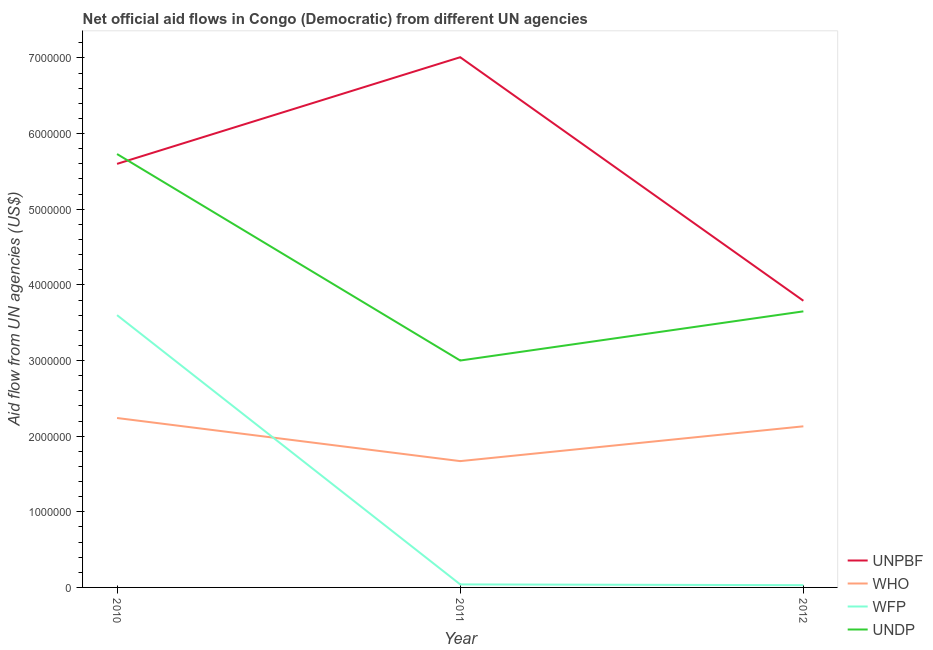How many different coloured lines are there?
Keep it short and to the point. 4. What is the amount of aid given by wfp in 2011?
Offer a very short reply. 4.00e+04. Across all years, what is the maximum amount of aid given by who?
Provide a short and direct response. 2.24e+06. Across all years, what is the minimum amount of aid given by unpbf?
Your answer should be very brief. 3.79e+06. What is the total amount of aid given by who in the graph?
Offer a very short reply. 6.04e+06. What is the difference between the amount of aid given by unpbf in 2010 and that in 2011?
Ensure brevity in your answer.  -1.41e+06. What is the difference between the amount of aid given by wfp in 2012 and the amount of aid given by unpbf in 2010?
Make the answer very short. -5.57e+06. What is the average amount of aid given by wfp per year?
Offer a very short reply. 1.22e+06. In the year 2011, what is the difference between the amount of aid given by unpbf and amount of aid given by who?
Your answer should be very brief. 5.34e+06. In how many years, is the amount of aid given by undp greater than 400000 US$?
Your answer should be very brief. 3. What is the ratio of the amount of aid given by undp in 2010 to that in 2012?
Keep it short and to the point. 1.57. Is the difference between the amount of aid given by who in 2010 and 2011 greater than the difference between the amount of aid given by unpbf in 2010 and 2011?
Offer a very short reply. Yes. What is the difference between the highest and the second highest amount of aid given by unpbf?
Offer a terse response. 1.41e+06. What is the difference between the highest and the lowest amount of aid given by unpbf?
Provide a succinct answer. 3.22e+06. In how many years, is the amount of aid given by who greater than the average amount of aid given by who taken over all years?
Your answer should be very brief. 2. Is the amount of aid given by unpbf strictly greater than the amount of aid given by undp over the years?
Ensure brevity in your answer.  No. Is the amount of aid given by wfp strictly less than the amount of aid given by undp over the years?
Your response must be concise. Yes. What is the difference between two consecutive major ticks on the Y-axis?
Provide a succinct answer. 1.00e+06. How many legend labels are there?
Ensure brevity in your answer.  4. How are the legend labels stacked?
Provide a short and direct response. Vertical. What is the title of the graph?
Ensure brevity in your answer.  Net official aid flows in Congo (Democratic) from different UN agencies. Does "Agriculture" appear as one of the legend labels in the graph?
Offer a very short reply. No. What is the label or title of the X-axis?
Provide a succinct answer. Year. What is the label or title of the Y-axis?
Give a very brief answer. Aid flow from UN agencies (US$). What is the Aid flow from UN agencies (US$) of UNPBF in 2010?
Keep it short and to the point. 5.60e+06. What is the Aid flow from UN agencies (US$) of WHO in 2010?
Your answer should be compact. 2.24e+06. What is the Aid flow from UN agencies (US$) of WFP in 2010?
Ensure brevity in your answer.  3.60e+06. What is the Aid flow from UN agencies (US$) of UNDP in 2010?
Provide a succinct answer. 5.73e+06. What is the Aid flow from UN agencies (US$) in UNPBF in 2011?
Give a very brief answer. 7.01e+06. What is the Aid flow from UN agencies (US$) in WHO in 2011?
Offer a very short reply. 1.67e+06. What is the Aid flow from UN agencies (US$) of UNDP in 2011?
Your response must be concise. 3.00e+06. What is the Aid flow from UN agencies (US$) in UNPBF in 2012?
Offer a very short reply. 3.79e+06. What is the Aid flow from UN agencies (US$) in WHO in 2012?
Your response must be concise. 2.13e+06. What is the Aid flow from UN agencies (US$) in WFP in 2012?
Your response must be concise. 3.00e+04. What is the Aid flow from UN agencies (US$) of UNDP in 2012?
Provide a succinct answer. 3.65e+06. Across all years, what is the maximum Aid flow from UN agencies (US$) in UNPBF?
Your answer should be very brief. 7.01e+06. Across all years, what is the maximum Aid flow from UN agencies (US$) in WHO?
Provide a succinct answer. 2.24e+06. Across all years, what is the maximum Aid flow from UN agencies (US$) in WFP?
Your answer should be very brief. 3.60e+06. Across all years, what is the maximum Aid flow from UN agencies (US$) of UNDP?
Your answer should be very brief. 5.73e+06. Across all years, what is the minimum Aid flow from UN agencies (US$) of UNPBF?
Keep it short and to the point. 3.79e+06. Across all years, what is the minimum Aid flow from UN agencies (US$) of WHO?
Your response must be concise. 1.67e+06. Across all years, what is the minimum Aid flow from UN agencies (US$) in UNDP?
Your answer should be very brief. 3.00e+06. What is the total Aid flow from UN agencies (US$) in UNPBF in the graph?
Provide a succinct answer. 1.64e+07. What is the total Aid flow from UN agencies (US$) in WHO in the graph?
Ensure brevity in your answer.  6.04e+06. What is the total Aid flow from UN agencies (US$) in WFP in the graph?
Offer a very short reply. 3.67e+06. What is the total Aid flow from UN agencies (US$) in UNDP in the graph?
Offer a terse response. 1.24e+07. What is the difference between the Aid flow from UN agencies (US$) of UNPBF in 2010 and that in 2011?
Keep it short and to the point. -1.41e+06. What is the difference between the Aid flow from UN agencies (US$) of WHO in 2010 and that in 2011?
Provide a succinct answer. 5.70e+05. What is the difference between the Aid flow from UN agencies (US$) of WFP in 2010 and that in 2011?
Offer a terse response. 3.56e+06. What is the difference between the Aid flow from UN agencies (US$) of UNDP in 2010 and that in 2011?
Provide a short and direct response. 2.73e+06. What is the difference between the Aid flow from UN agencies (US$) in UNPBF in 2010 and that in 2012?
Provide a succinct answer. 1.81e+06. What is the difference between the Aid flow from UN agencies (US$) in WHO in 2010 and that in 2012?
Your answer should be very brief. 1.10e+05. What is the difference between the Aid flow from UN agencies (US$) in WFP in 2010 and that in 2012?
Provide a short and direct response. 3.57e+06. What is the difference between the Aid flow from UN agencies (US$) in UNDP in 2010 and that in 2012?
Give a very brief answer. 2.08e+06. What is the difference between the Aid flow from UN agencies (US$) of UNPBF in 2011 and that in 2012?
Keep it short and to the point. 3.22e+06. What is the difference between the Aid flow from UN agencies (US$) in WHO in 2011 and that in 2012?
Keep it short and to the point. -4.60e+05. What is the difference between the Aid flow from UN agencies (US$) in WFP in 2011 and that in 2012?
Provide a succinct answer. 10000. What is the difference between the Aid flow from UN agencies (US$) in UNDP in 2011 and that in 2012?
Give a very brief answer. -6.50e+05. What is the difference between the Aid flow from UN agencies (US$) in UNPBF in 2010 and the Aid flow from UN agencies (US$) in WHO in 2011?
Make the answer very short. 3.93e+06. What is the difference between the Aid flow from UN agencies (US$) of UNPBF in 2010 and the Aid flow from UN agencies (US$) of WFP in 2011?
Ensure brevity in your answer.  5.56e+06. What is the difference between the Aid flow from UN agencies (US$) of UNPBF in 2010 and the Aid flow from UN agencies (US$) of UNDP in 2011?
Make the answer very short. 2.60e+06. What is the difference between the Aid flow from UN agencies (US$) of WHO in 2010 and the Aid flow from UN agencies (US$) of WFP in 2011?
Your response must be concise. 2.20e+06. What is the difference between the Aid flow from UN agencies (US$) of WHO in 2010 and the Aid flow from UN agencies (US$) of UNDP in 2011?
Your answer should be very brief. -7.60e+05. What is the difference between the Aid flow from UN agencies (US$) of WFP in 2010 and the Aid flow from UN agencies (US$) of UNDP in 2011?
Ensure brevity in your answer.  6.00e+05. What is the difference between the Aid flow from UN agencies (US$) in UNPBF in 2010 and the Aid flow from UN agencies (US$) in WHO in 2012?
Your response must be concise. 3.47e+06. What is the difference between the Aid flow from UN agencies (US$) of UNPBF in 2010 and the Aid flow from UN agencies (US$) of WFP in 2012?
Provide a short and direct response. 5.57e+06. What is the difference between the Aid flow from UN agencies (US$) of UNPBF in 2010 and the Aid flow from UN agencies (US$) of UNDP in 2012?
Offer a very short reply. 1.95e+06. What is the difference between the Aid flow from UN agencies (US$) in WHO in 2010 and the Aid flow from UN agencies (US$) in WFP in 2012?
Ensure brevity in your answer.  2.21e+06. What is the difference between the Aid flow from UN agencies (US$) of WHO in 2010 and the Aid flow from UN agencies (US$) of UNDP in 2012?
Offer a terse response. -1.41e+06. What is the difference between the Aid flow from UN agencies (US$) in UNPBF in 2011 and the Aid flow from UN agencies (US$) in WHO in 2012?
Your answer should be compact. 4.88e+06. What is the difference between the Aid flow from UN agencies (US$) in UNPBF in 2011 and the Aid flow from UN agencies (US$) in WFP in 2012?
Provide a succinct answer. 6.98e+06. What is the difference between the Aid flow from UN agencies (US$) of UNPBF in 2011 and the Aid flow from UN agencies (US$) of UNDP in 2012?
Your answer should be compact. 3.36e+06. What is the difference between the Aid flow from UN agencies (US$) of WHO in 2011 and the Aid flow from UN agencies (US$) of WFP in 2012?
Offer a terse response. 1.64e+06. What is the difference between the Aid flow from UN agencies (US$) of WHO in 2011 and the Aid flow from UN agencies (US$) of UNDP in 2012?
Provide a short and direct response. -1.98e+06. What is the difference between the Aid flow from UN agencies (US$) in WFP in 2011 and the Aid flow from UN agencies (US$) in UNDP in 2012?
Ensure brevity in your answer.  -3.61e+06. What is the average Aid flow from UN agencies (US$) in UNPBF per year?
Ensure brevity in your answer.  5.47e+06. What is the average Aid flow from UN agencies (US$) in WHO per year?
Provide a short and direct response. 2.01e+06. What is the average Aid flow from UN agencies (US$) of WFP per year?
Offer a terse response. 1.22e+06. What is the average Aid flow from UN agencies (US$) of UNDP per year?
Ensure brevity in your answer.  4.13e+06. In the year 2010, what is the difference between the Aid flow from UN agencies (US$) of UNPBF and Aid flow from UN agencies (US$) of WHO?
Your answer should be compact. 3.36e+06. In the year 2010, what is the difference between the Aid flow from UN agencies (US$) in UNPBF and Aid flow from UN agencies (US$) in WFP?
Provide a succinct answer. 2.00e+06. In the year 2010, what is the difference between the Aid flow from UN agencies (US$) of WHO and Aid flow from UN agencies (US$) of WFP?
Ensure brevity in your answer.  -1.36e+06. In the year 2010, what is the difference between the Aid flow from UN agencies (US$) in WHO and Aid flow from UN agencies (US$) in UNDP?
Give a very brief answer. -3.49e+06. In the year 2010, what is the difference between the Aid flow from UN agencies (US$) in WFP and Aid flow from UN agencies (US$) in UNDP?
Your response must be concise. -2.13e+06. In the year 2011, what is the difference between the Aid flow from UN agencies (US$) in UNPBF and Aid flow from UN agencies (US$) in WHO?
Give a very brief answer. 5.34e+06. In the year 2011, what is the difference between the Aid flow from UN agencies (US$) of UNPBF and Aid flow from UN agencies (US$) of WFP?
Your answer should be very brief. 6.97e+06. In the year 2011, what is the difference between the Aid flow from UN agencies (US$) of UNPBF and Aid flow from UN agencies (US$) of UNDP?
Your answer should be compact. 4.01e+06. In the year 2011, what is the difference between the Aid flow from UN agencies (US$) of WHO and Aid flow from UN agencies (US$) of WFP?
Provide a short and direct response. 1.63e+06. In the year 2011, what is the difference between the Aid flow from UN agencies (US$) of WHO and Aid flow from UN agencies (US$) of UNDP?
Provide a short and direct response. -1.33e+06. In the year 2011, what is the difference between the Aid flow from UN agencies (US$) in WFP and Aid flow from UN agencies (US$) in UNDP?
Offer a terse response. -2.96e+06. In the year 2012, what is the difference between the Aid flow from UN agencies (US$) in UNPBF and Aid flow from UN agencies (US$) in WHO?
Provide a succinct answer. 1.66e+06. In the year 2012, what is the difference between the Aid flow from UN agencies (US$) of UNPBF and Aid flow from UN agencies (US$) of WFP?
Ensure brevity in your answer.  3.76e+06. In the year 2012, what is the difference between the Aid flow from UN agencies (US$) of UNPBF and Aid flow from UN agencies (US$) of UNDP?
Offer a very short reply. 1.40e+05. In the year 2012, what is the difference between the Aid flow from UN agencies (US$) in WHO and Aid flow from UN agencies (US$) in WFP?
Your answer should be compact. 2.10e+06. In the year 2012, what is the difference between the Aid flow from UN agencies (US$) in WHO and Aid flow from UN agencies (US$) in UNDP?
Offer a terse response. -1.52e+06. In the year 2012, what is the difference between the Aid flow from UN agencies (US$) in WFP and Aid flow from UN agencies (US$) in UNDP?
Offer a very short reply. -3.62e+06. What is the ratio of the Aid flow from UN agencies (US$) of UNPBF in 2010 to that in 2011?
Ensure brevity in your answer.  0.8. What is the ratio of the Aid flow from UN agencies (US$) in WHO in 2010 to that in 2011?
Keep it short and to the point. 1.34. What is the ratio of the Aid flow from UN agencies (US$) in WFP in 2010 to that in 2011?
Give a very brief answer. 90. What is the ratio of the Aid flow from UN agencies (US$) of UNDP in 2010 to that in 2011?
Provide a succinct answer. 1.91. What is the ratio of the Aid flow from UN agencies (US$) in UNPBF in 2010 to that in 2012?
Keep it short and to the point. 1.48. What is the ratio of the Aid flow from UN agencies (US$) in WHO in 2010 to that in 2012?
Give a very brief answer. 1.05. What is the ratio of the Aid flow from UN agencies (US$) in WFP in 2010 to that in 2012?
Give a very brief answer. 120. What is the ratio of the Aid flow from UN agencies (US$) in UNDP in 2010 to that in 2012?
Offer a terse response. 1.57. What is the ratio of the Aid flow from UN agencies (US$) of UNPBF in 2011 to that in 2012?
Ensure brevity in your answer.  1.85. What is the ratio of the Aid flow from UN agencies (US$) of WHO in 2011 to that in 2012?
Your answer should be compact. 0.78. What is the ratio of the Aid flow from UN agencies (US$) in WFP in 2011 to that in 2012?
Give a very brief answer. 1.33. What is the ratio of the Aid flow from UN agencies (US$) of UNDP in 2011 to that in 2012?
Offer a very short reply. 0.82. What is the difference between the highest and the second highest Aid flow from UN agencies (US$) in UNPBF?
Keep it short and to the point. 1.41e+06. What is the difference between the highest and the second highest Aid flow from UN agencies (US$) of WHO?
Give a very brief answer. 1.10e+05. What is the difference between the highest and the second highest Aid flow from UN agencies (US$) of WFP?
Offer a terse response. 3.56e+06. What is the difference between the highest and the second highest Aid flow from UN agencies (US$) of UNDP?
Offer a very short reply. 2.08e+06. What is the difference between the highest and the lowest Aid flow from UN agencies (US$) in UNPBF?
Your answer should be compact. 3.22e+06. What is the difference between the highest and the lowest Aid flow from UN agencies (US$) in WHO?
Give a very brief answer. 5.70e+05. What is the difference between the highest and the lowest Aid flow from UN agencies (US$) of WFP?
Make the answer very short. 3.57e+06. What is the difference between the highest and the lowest Aid flow from UN agencies (US$) of UNDP?
Provide a succinct answer. 2.73e+06. 